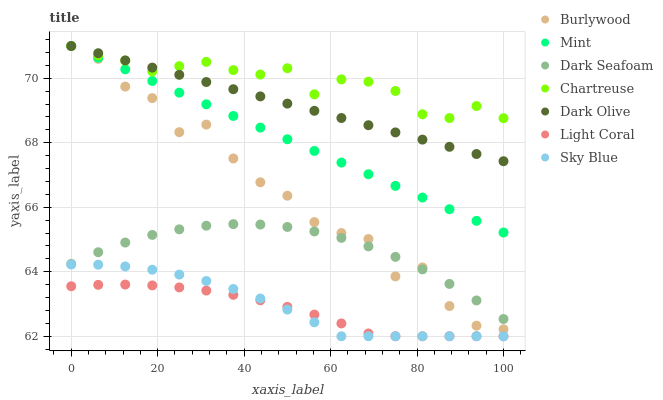Does Light Coral have the minimum area under the curve?
Answer yes or no. Yes. Does Chartreuse have the maximum area under the curve?
Answer yes or no. Yes. Does Dark Olive have the minimum area under the curve?
Answer yes or no. No. Does Dark Olive have the maximum area under the curve?
Answer yes or no. No. Is Dark Olive the smoothest?
Answer yes or no. Yes. Is Burlywood the roughest?
Answer yes or no. Yes. Is Chartreuse the smoothest?
Answer yes or no. No. Is Chartreuse the roughest?
Answer yes or no. No. Does Light Coral have the lowest value?
Answer yes or no. Yes. Does Dark Olive have the lowest value?
Answer yes or no. No. Does Mint have the highest value?
Answer yes or no. Yes. Does Light Coral have the highest value?
Answer yes or no. No. Is Light Coral less than Dark Olive?
Answer yes or no. Yes. Is Dark Olive greater than Sky Blue?
Answer yes or no. Yes. Does Burlywood intersect Dark Olive?
Answer yes or no. Yes. Is Burlywood less than Dark Olive?
Answer yes or no. No. Is Burlywood greater than Dark Olive?
Answer yes or no. No. Does Light Coral intersect Dark Olive?
Answer yes or no. No. 